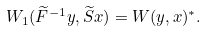<formula> <loc_0><loc_0><loc_500><loc_500>W _ { 1 } ( \widetilde { F } ^ { - 1 } y , \widetilde { S } x ) = W ( y , x ) ^ { * } .</formula> 